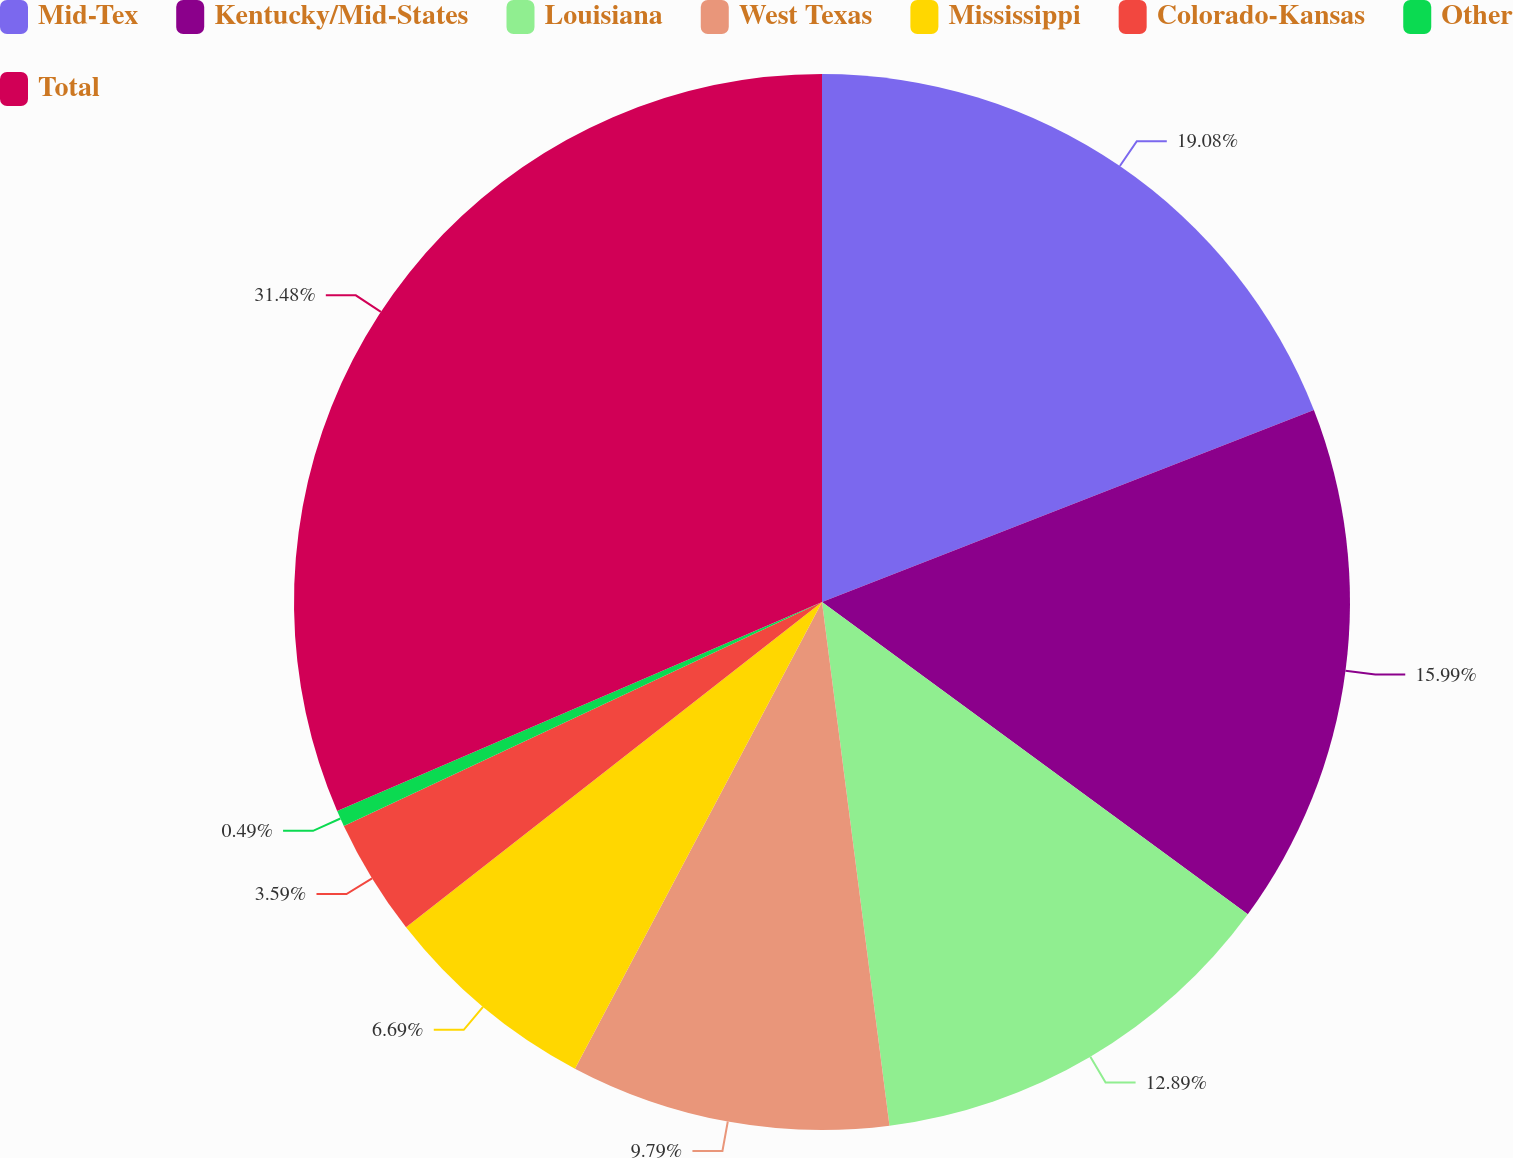Convert chart to OTSL. <chart><loc_0><loc_0><loc_500><loc_500><pie_chart><fcel>Mid-Tex<fcel>Kentucky/Mid-States<fcel>Louisiana<fcel>West Texas<fcel>Mississippi<fcel>Colorado-Kansas<fcel>Other<fcel>Total<nl><fcel>19.08%<fcel>15.99%<fcel>12.89%<fcel>9.79%<fcel>6.69%<fcel>3.59%<fcel>0.49%<fcel>31.48%<nl></chart> 